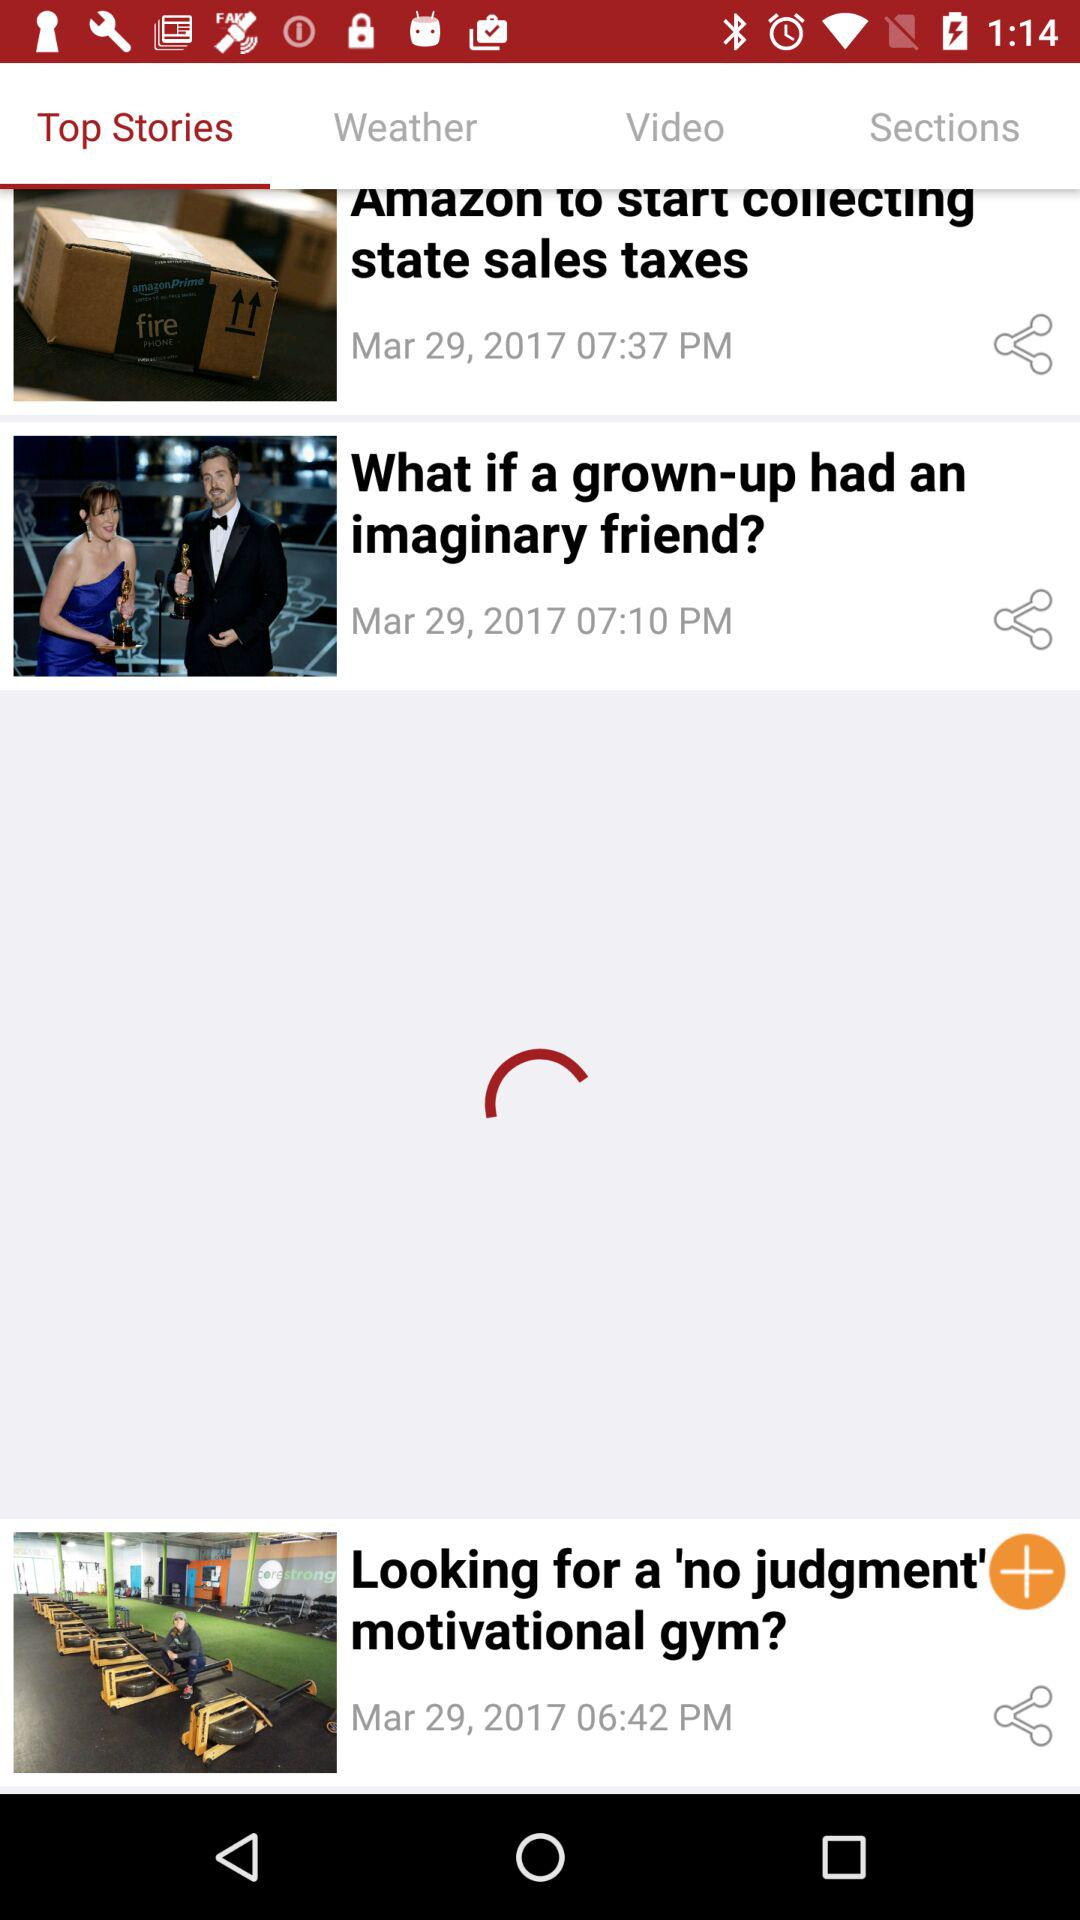What's the posted time of "What if a grown-up had an imaginary friend"? The posted time is 7:10 pm. 